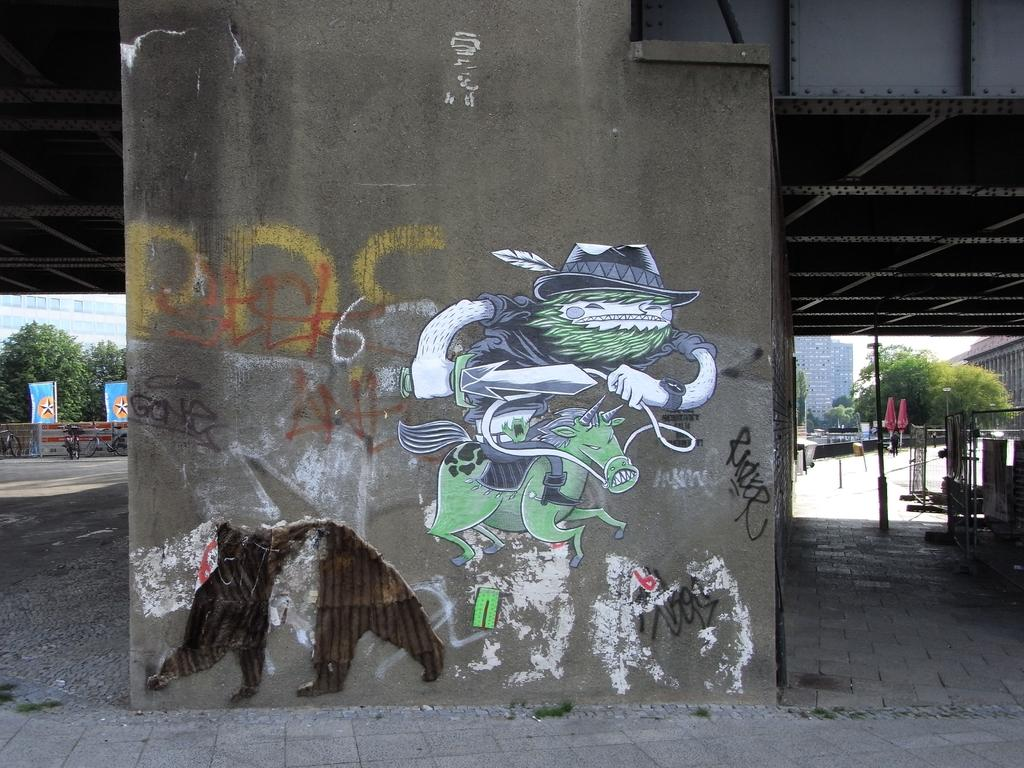What type of structure is present in the image? There is a concrete wall in the image. What is featured on the wall? There are paintings on the wall. What type of vegetation can be seen on the right side of the image? There are green trees on the right side of the image. How many accounts are mentioned in the image? There are no accounts mentioned in the image; it features a concrete wall with paintings and green trees. What type of balance is depicted in the image? There is no balance depicted in the image; it only shows a concrete wall, paintings, and green trees. 